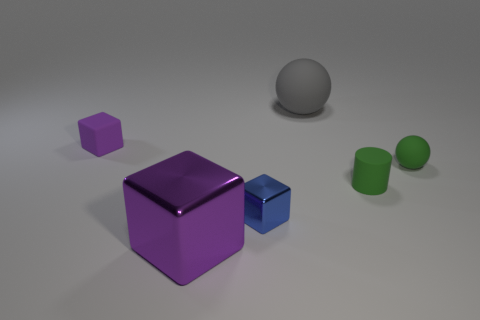What size is the rubber ball that is behind the purple matte cube?
Give a very brief answer. Large. What size is the purple block that is to the right of the small rubber thing that is to the left of the tiny blue cube?
Your response must be concise. Large. There is a green sphere that is the same size as the rubber cylinder; what is it made of?
Your response must be concise. Rubber. Are there any small rubber objects to the left of the small green rubber ball?
Give a very brief answer. Yes. Are there the same number of green matte spheres that are in front of the matte cube and large cubes?
Your response must be concise. Yes. What shape is the blue thing that is the same size as the purple rubber cube?
Your answer should be very brief. Cube. What is the material of the small purple block?
Offer a terse response. Rubber. There is a small rubber object that is both behind the small green cylinder and to the left of the small green ball; what is its color?
Your answer should be compact. Purple. Is the number of green balls that are behind the tiny matte ball the same as the number of gray things to the right of the matte cube?
Keep it short and to the point. No. There is a large object that is made of the same material as the tiny purple object; what color is it?
Offer a terse response. Gray. 